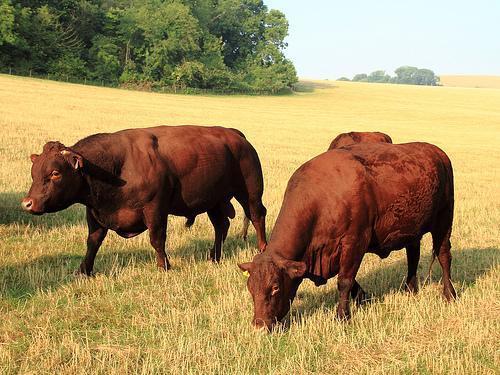How many cows are there?
Give a very brief answer. 3. 